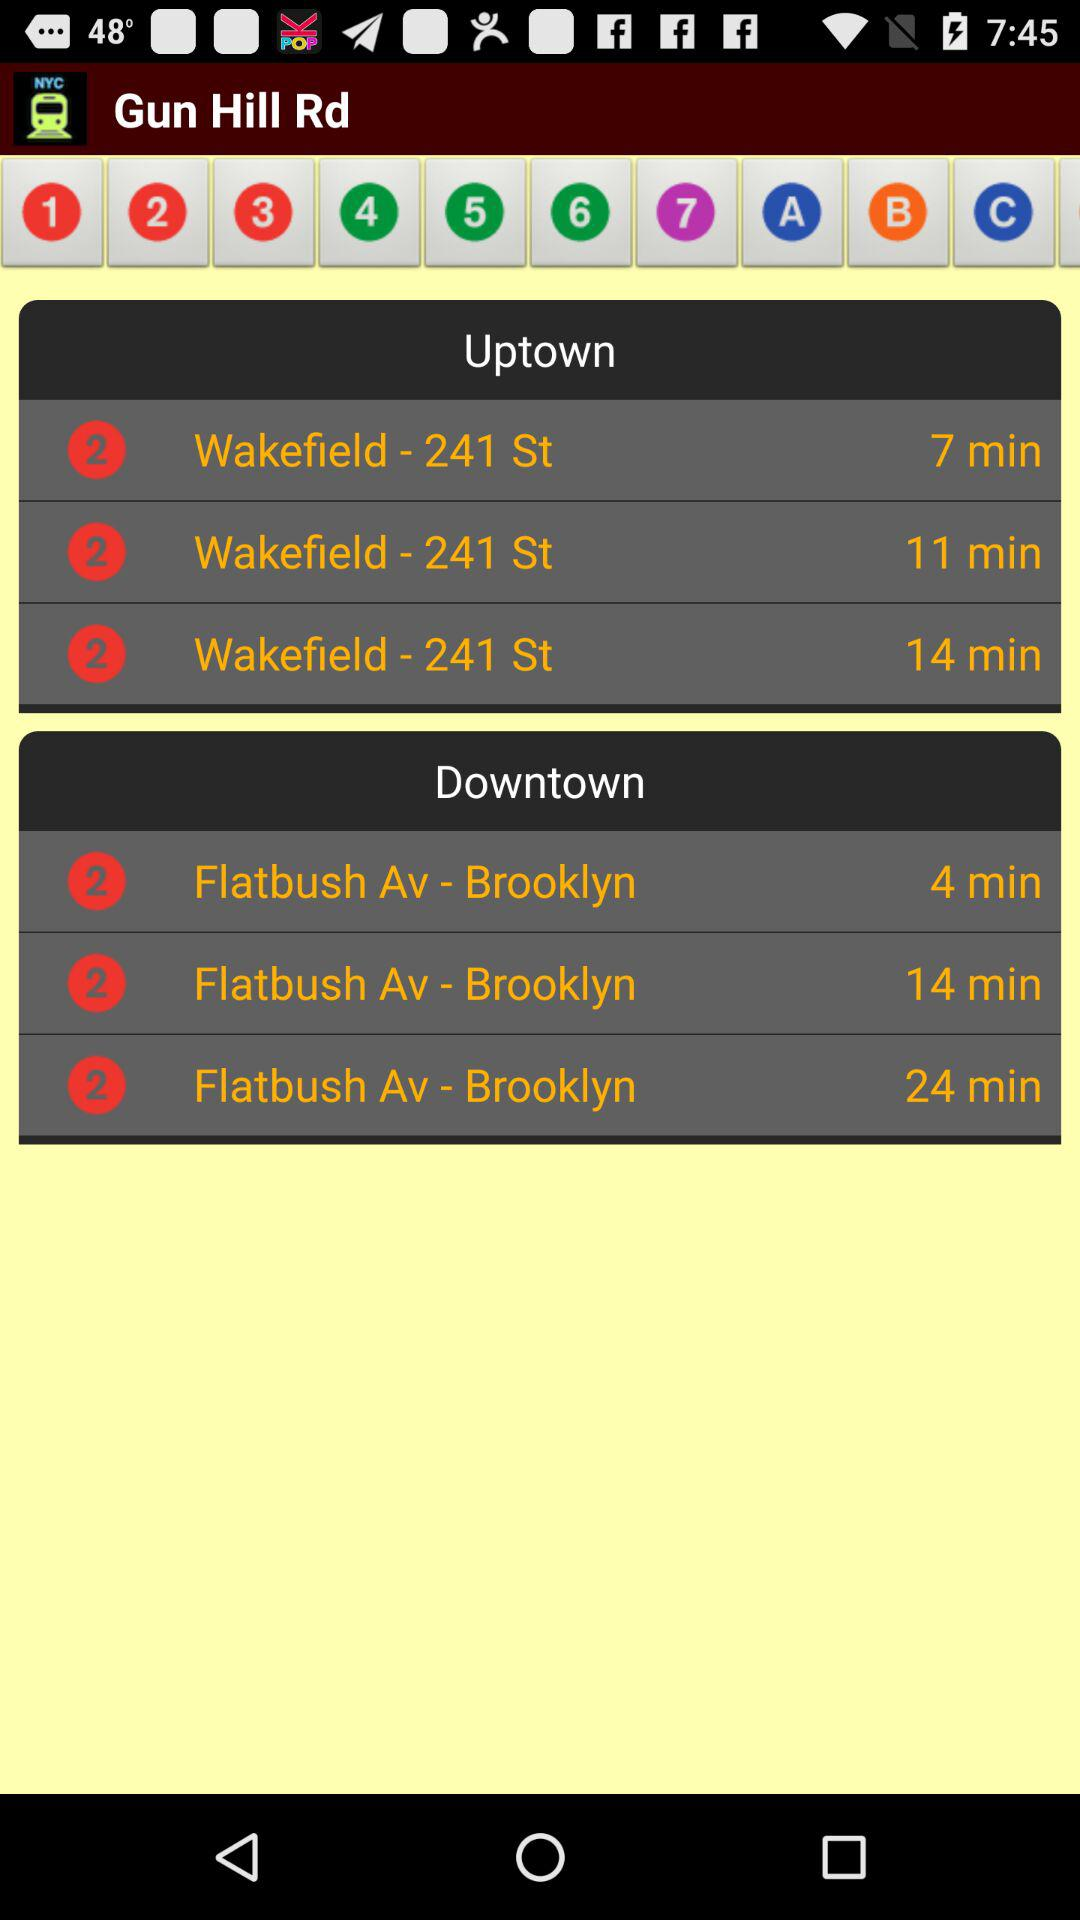What are the different timings of "Uptown"? The different timings are 7 minutes, 11 minutes and 14 minutes. 